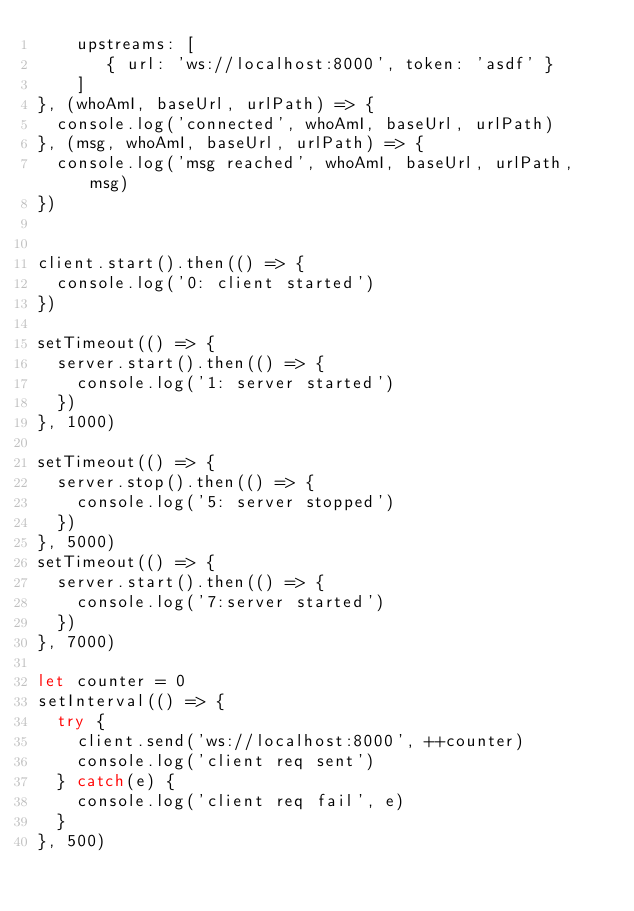Convert code to text. <code><loc_0><loc_0><loc_500><loc_500><_JavaScript_>    upstreams: [
       { url: 'ws://localhost:8000', token: 'asdf' }
    ]
}, (whoAmI, baseUrl, urlPath) => {
  console.log('connected', whoAmI, baseUrl, urlPath)
}, (msg, whoAmI, baseUrl, urlPath) => {
  console.log('msg reached', whoAmI, baseUrl, urlPath, msg)
})


client.start().then(() => {
  console.log('0: client started')
})

setTimeout(() => {
  server.start().then(() => {
    console.log('1: server started')
  })
}, 1000)
  
setTimeout(() => {
  server.stop().then(() => {
    console.log('5: server stopped')
  })
}, 5000)
setTimeout(() => {
  server.start().then(() => {
    console.log('7:server started')
  })
}, 7000)

let counter = 0
setInterval(() => {
  try {
    client.send('ws://localhost:8000', ++counter)
    console.log('client req sent')
  } catch(e) {
    console.log('client req fail', e)
  }
}, 500)
</code> 